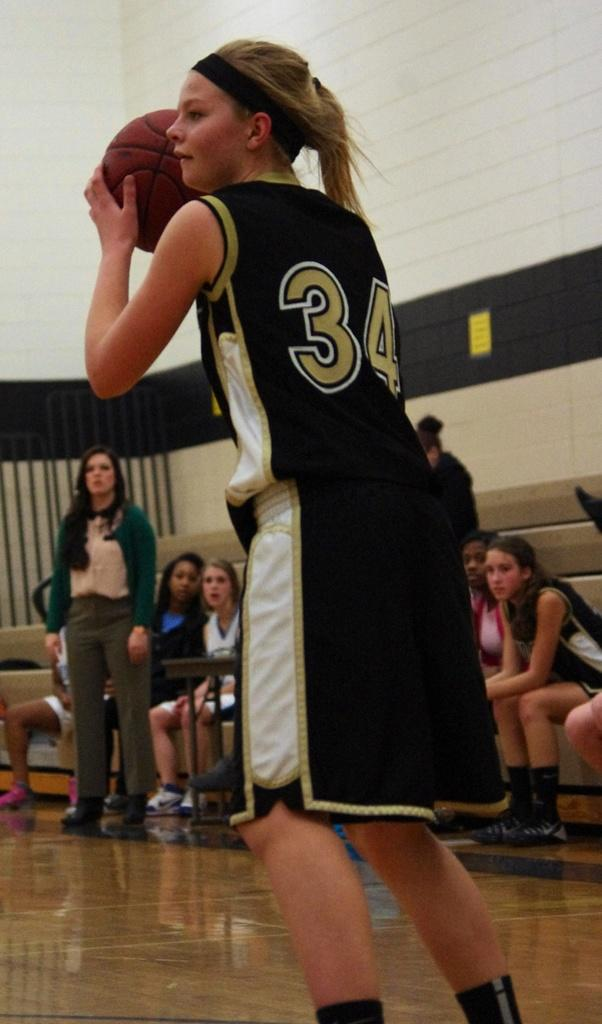<image>
Create a compact narrative representing the image presented. Number 34 has the ball as her teammates look on. 